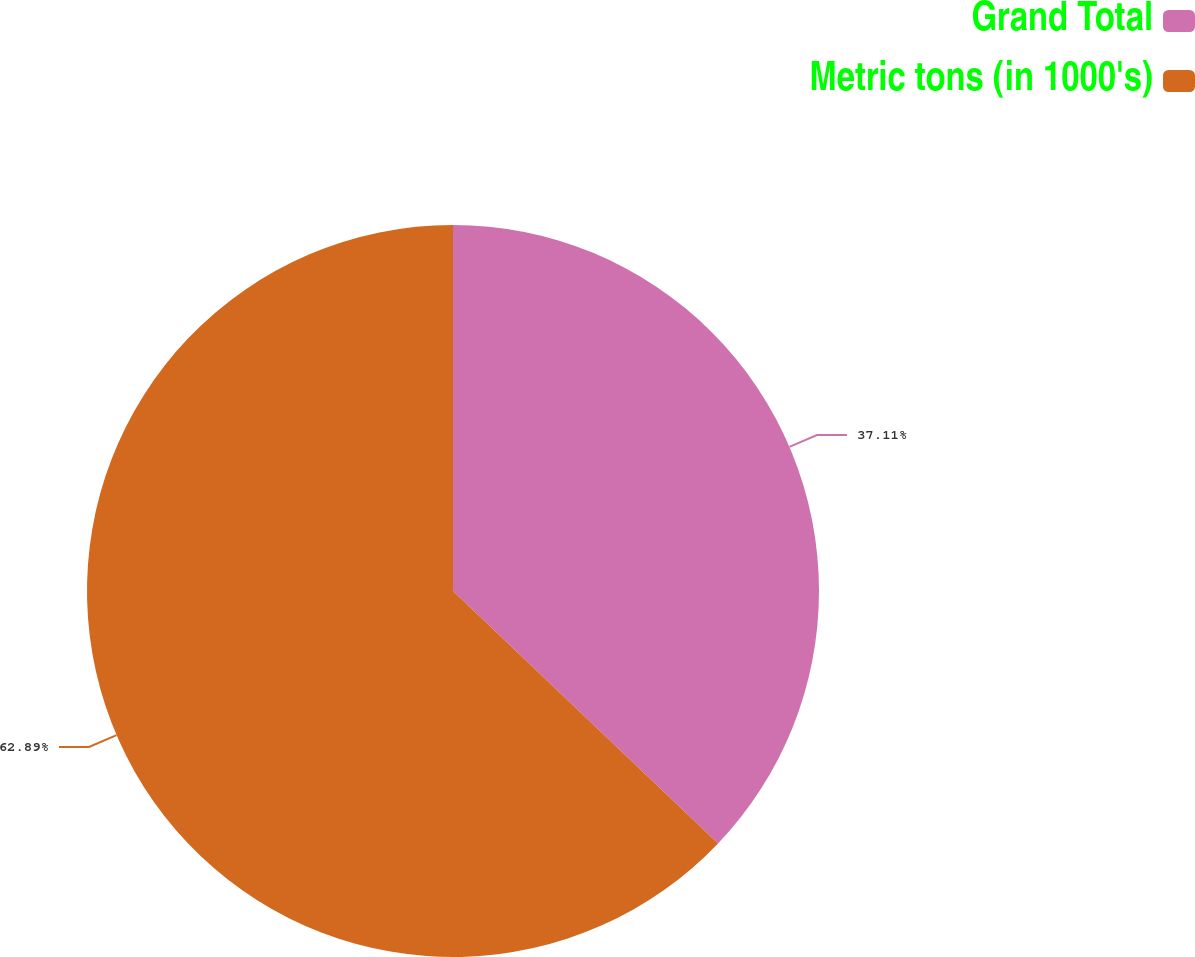Convert chart. <chart><loc_0><loc_0><loc_500><loc_500><pie_chart><fcel>Grand Total<fcel>Metric tons (in 1000's)<nl><fcel>37.11%<fcel>62.89%<nl></chart> 